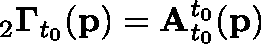<formula> <loc_0><loc_0><loc_500><loc_500>{ } _ { 2 } \Gamma _ { t _ { 0 } } ( p ) = A _ { t _ { 0 } } ^ { t _ { 0 } } ( p )</formula> 